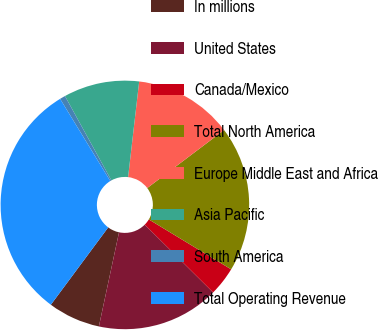<chart> <loc_0><loc_0><loc_500><loc_500><pie_chart><fcel>In millions<fcel>United States<fcel>Canada/Mexico<fcel>Total North America<fcel>Europe Middle East and Africa<fcel>Asia Pacific<fcel>South America<fcel>Total Operating Revenue<nl><fcel>6.8%<fcel>15.92%<fcel>3.76%<fcel>18.96%<fcel>12.88%<fcel>9.84%<fcel>0.72%<fcel>31.12%<nl></chart> 